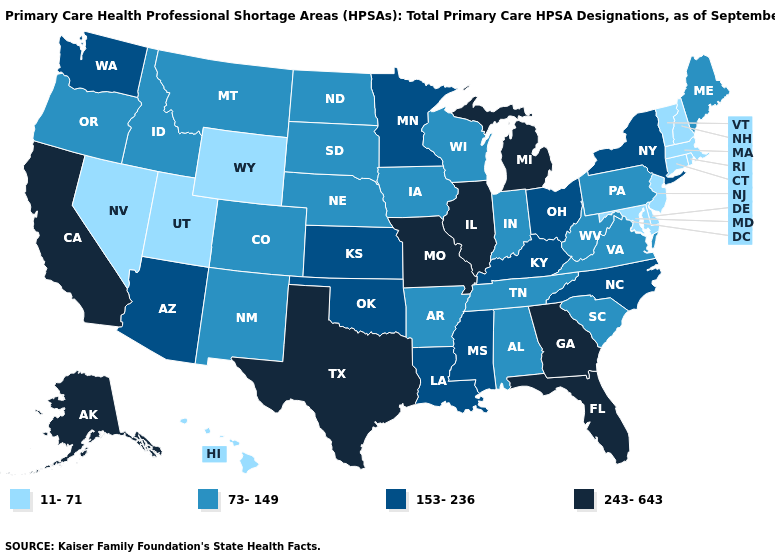Does Alaska have the lowest value in the USA?
Answer briefly. No. What is the value of Washington?
Keep it brief. 153-236. Is the legend a continuous bar?
Quick response, please. No. What is the value of Massachusetts?
Write a very short answer. 11-71. Name the states that have a value in the range 153-236?
Give a very brief answer. Arizona, Kansas, Kentucky, Louisiana, Minnesota, Mississippi, New York, North Carolina, Ohio, Oklahoma, Washington. What is the value of New Mexico?
Keep it brief. 73-149. Name the states that have a value in the range 11-71?
Quick response, please. Connecticut, Delaware, Hawaii, Maryland, Massachusetts, Nevada, New Hampshire, New Jersey, Rhode Island, Utah, Vermont, Wyoming. Name the states that have a value in the range 243-643?
Give a very brief answer. Alaska, California, Florida, Georgia, Illinois, Michigan, Missouri, Texas. Which states have the lowest value in the West?
Quick response, please. Hawaii, Nevada, Utah, Wyoming. What is the lowest value in the USA?
Short answer required. 11-71. What is the value of Montana?
Quick response, please. 73-149. What is the value of Delaware?
Concise answer only. 11-71. Among the states that border New Jersey , which have the highest value?
Keep it brief. New York. Does the first symbol in the legend represent the smallest category?
Keep it brief. Yes. How many symbols are there in the legend?
Answer briefly. 4. 